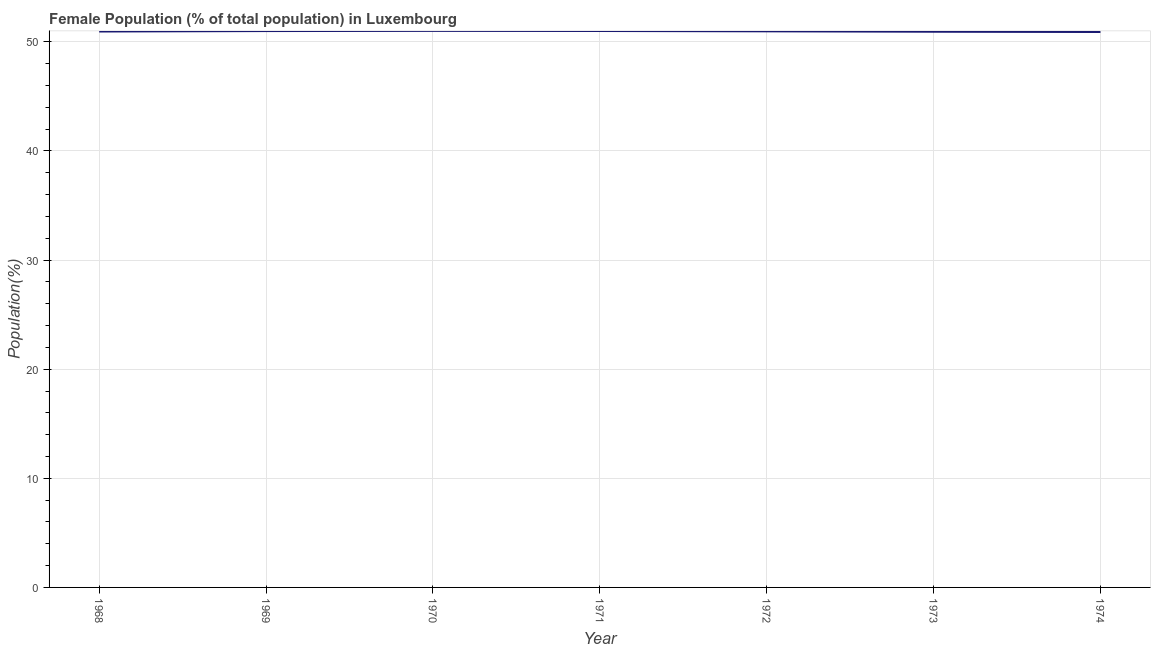What is the female population in 1972?
Provide a succinct answer. 50.96. Across all years, what is the maximum female population?
Offer a terse response. 51. Across all years, what is the minimum female population?
Offer a very short reply. 50.9. In which year was the female population minimum?
Offer a terse response. 1974. What is the sum of the female population?
Give a very brief answer. 356.7. What is the difference between the female population in 1969 and 1974?
Your answer should be very brief. 0.09. What is the average female population per year?
Ensure brevity in your answer.  50.96. What is the median female population?
Make the answer very short. 50.96. What is the ratio of the female population in 1968 to that in 1969?
Your response must be concise. 1. Is the difference between the female population in 1969 and 1971 greater than the difference between any two years?
Your answer should be very brief. No. What is the difference between the highest and the second highest female population?
Ensure brevity in your answer.  0.01. What is the difference between the highest and the lowest female population?
Offer a very short reply. 0.1. Does the female population monotonically increase over the years?
Make the answer very short. No. What is the difference between two consecutive major ticks on the Y-axis?
Make the answer very short. 10. Does the graph contain any zero values?
Provide a short and direct response. No. What is the title of the graph?
Make the answer very short. Female Population (% of total population) in Luxembourg. What is the label or title of the X-axis?
Make the answer very short. Year. What is the label or title of the Y-axis?
Make the answer very short. Population(%). What is the Population(%) in 1968?
Offer a very short reply. 50.94. What is the Population(%) in 1969?
Your response must be concise. 50.98. What is the Population(%) of 1970?
Provide a succinct answer. 51. What is the Population(%) in 1971?
Give a very brief answer. 50.99. What is the Population(%) in 1972?
Your response must be concise. 50.96. What is the Population(%) of 1973?
Ensure brevity in your answer.  50.92. What is the Population(%) in 1974?
Keep it short and to the point. 50.9. What is the difference between the Population(%) in 1968 and 1969?
Your response must be concise. -0.04. What is the difference between the Population(%) in 1968 and 1970?
Keep it short and to the point. -0.06. What is the difference between the Population(%) in 1968 and 1971?
Provide a succinct answer. -0.05. What is the difference between the Population(%) in 1968 and 1972?
Ensure brevity in your answer.  -0.02. What is the difference between the Population(%) in 1968 and 1973?
Offer a very short reply. 0.02. What is the difference between the Population(%) in 1968 and 1974?
Your answer should be very brief. 0.04. What is the difference between the Population(%) in 1969 and 1970?
Provide a succinct answer. -0.02. What is the difference between the Population(%) in 1969 and 1971?
Your answer should be compact. -0.01. What is the difference between the Population(%) in 1969 and 1972?
Ensure brevity in your answer.  0.02. What is the difference between the Population(%) in 1969 and 1973?
Offer a very short reply. 0.06. What is the difference between the Population(%) in 1969 and 1974?
Offer a terse response. 0.09. What is the difference between the Population(%) in 1970 and 1971?
Keep it short and to the point. 0.01. What is the difference between the Population(%) in 1970 and 1972?
Give a very brief answer. 0.04. What is the difference between the Population(%) in 1970 and 1973?
Make the answer very short. 0.08. What is the difference between the Population(%) in 1970 and 1974?
Provide a short and direct response. 0.1. What is the difference between the Population(%) in 1971 and 1972?
Provide a succinct answer. 0.03. What is the difference between the Population(%) in 1971 and 1973?
Provide a short and direct response. 0.07. What is the difference between the Population(%) in 1971 and 1974?
Provide a short and direct response. 0.09. What is the difference between the Population(%) in 1972 and 1973?
Offer a very short reply. 0.04. What is the difference between the Population(%) in 1972 and 1974?
Offer a very short reply. 0.06. What is the difference between the Population(%) in 1973 and 1974?
Offer a very short reply. 0.02. What is the ratio of the Population(%) in 1968 to that in 1970?
Ensure brevity in your answer.  1. What is the ratio of the Population(%) in 1968 to that in 1971?
Your answer should be very brief. 1. What is the ratio of the Population(%) in 1968 to that in 1972?
Keep it short and to the point. 1. What is the ratio of the Population(%) in 1968 to that in 1973?
Ensure brevity in your answer.  1. What is the ratio of the Population(%) in 1968 to that in 1974?
Offer a very short reply. 1. What is the ratio of the Population(%) in 1969 to that in 1970?
Provide a short and direct response. 1. What is the ratio of the Population(%) in 1969 to that in 1972?
Provide a short and direct response. 1. What is the ratio of the Population(%) in 1969 to that in 1973?
Ensure brevity in your answer.  1. What is the ratio of the Population(%) in 1970 to that in 1972?
Your response must be concise. 1. What is the ratio of the Population(%) in 1970 to that in 1973?
Keep it short and to the point. 1. What is the ratio of the Population(%) in 1970 to that in 1974?
Ensure brevity in your answer.  1. What is the ratio of the Population(%) in 1971 to that in 1972?
Offer a very short reply. 1. What is the ratio of the Population(%) in 1971 to that in 1974?
Offer a terse response. 1. What is the ratio of the Population(%) in 1972 to that in 1973?
Offer a terse response. 1. What is the ratio of the Population(%) in 1973 to that in 1974?
Provide a succinct answer. 1. 